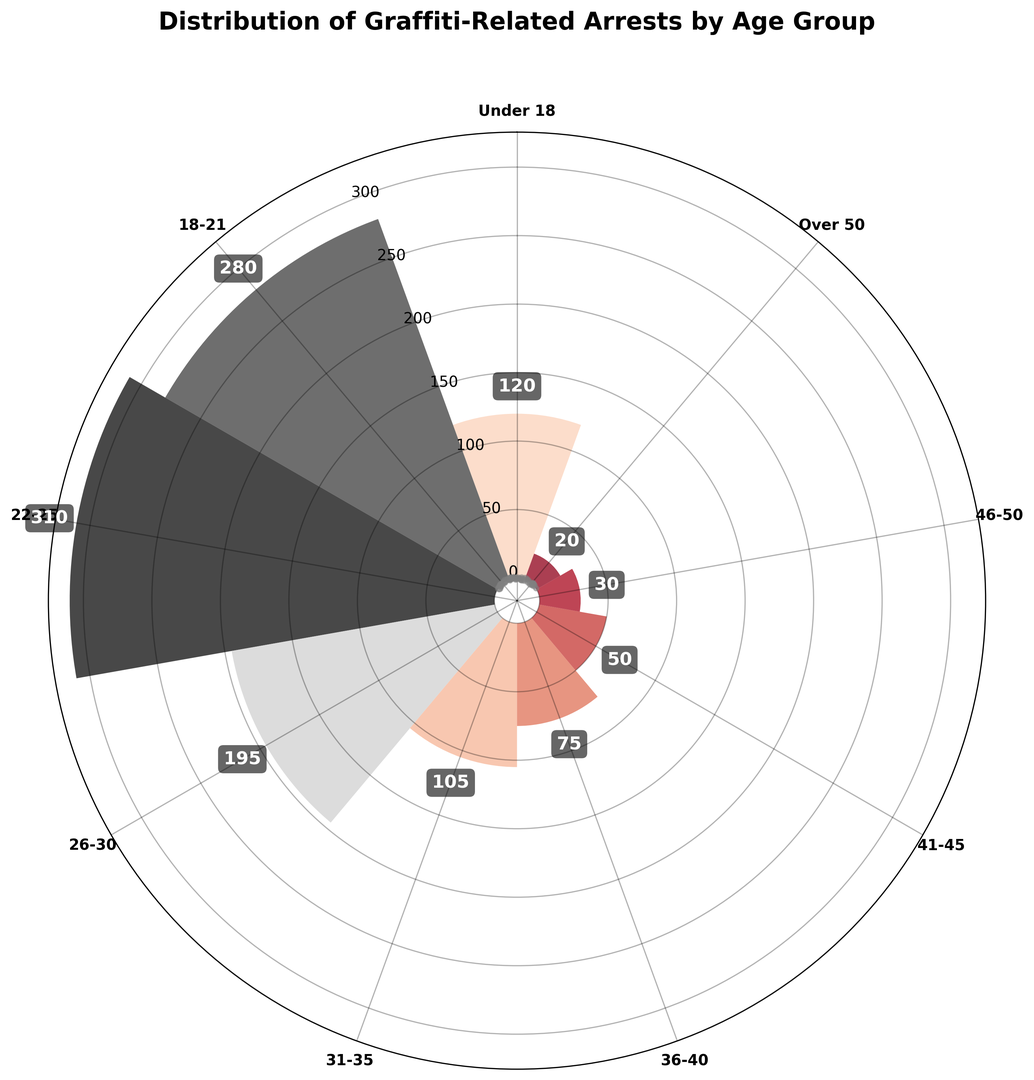Which age group has the highest number of graffiti-related arrests? The bars on the plot represent the number of graffiti-related arrests for each age group. By visually comparing the height (or length) of the bars, you can see that the age group 22-25 has the highest bar.
Answer: 22-25 Which age group has fewer arrests: 31-35 or 36-40? By comparing the height of the bars for the two age groups, you can see that the bar for the age group 36-40 is shorter than the bar for the age group 31-35.
Answer: 36-40 How many more arrests are there in the 18-21 group compared to the Under 18 group? First, find the value for the 18-21 arrests (280) and the Under 18 arrests (120). Subtract the Under 18 value from the 18-21 value, i.e., 280 - 120.
Answer: 160 Which age groups have arrests less than 100? Check the height of the bars to see which ones are under the tick mark for 100 arrests. The age groups 31-35, 36-40, 41-45, 46-50, and Over 50 all fall below this threshold.
Answer: 31-35, 36-40, 41-45, 46-50, Over 50 What is the average number of arrests for age groups 26-30, 31-35, and 36-40? Sum the arrests for 26-30 (195), 31-35 (105), and 36-40 (75), which is 195 + 105 + 75 = 375. Divide by the number of groups (3) to get the average, 375 / 3.
Answer: 125 How does the number of arrests for the age group 46-50 compare to those for the Over 50 group? Compare the height of the respective bars. The bar for the 46-50 group (30 arrests) is higher than the one for the Over 50 group (20 arrests).
Answer: 46-50 has more Is there an age group with exactly 50 arrests? Look for a bar that reaches up to the 50 arrest mark. The age group 41-45 has exactly 50 arrests.
Answer: Yes, 41-45 What is the difference between the highest and lowest number of arrests among all age groups? Identify the highest number of arrests (310 for 22-25) and the lowest number of arrests (20 for Over 50). Subtract the smallest value from the largest value, i.e., 310 - 20.
Answer: 290 Combine the arrests for Under 18 and Over 50 age groups. What is the total? Sum the arrests for Under 18 (120) and Over 50 (20), which is 120 + 20.
Answer: 140 